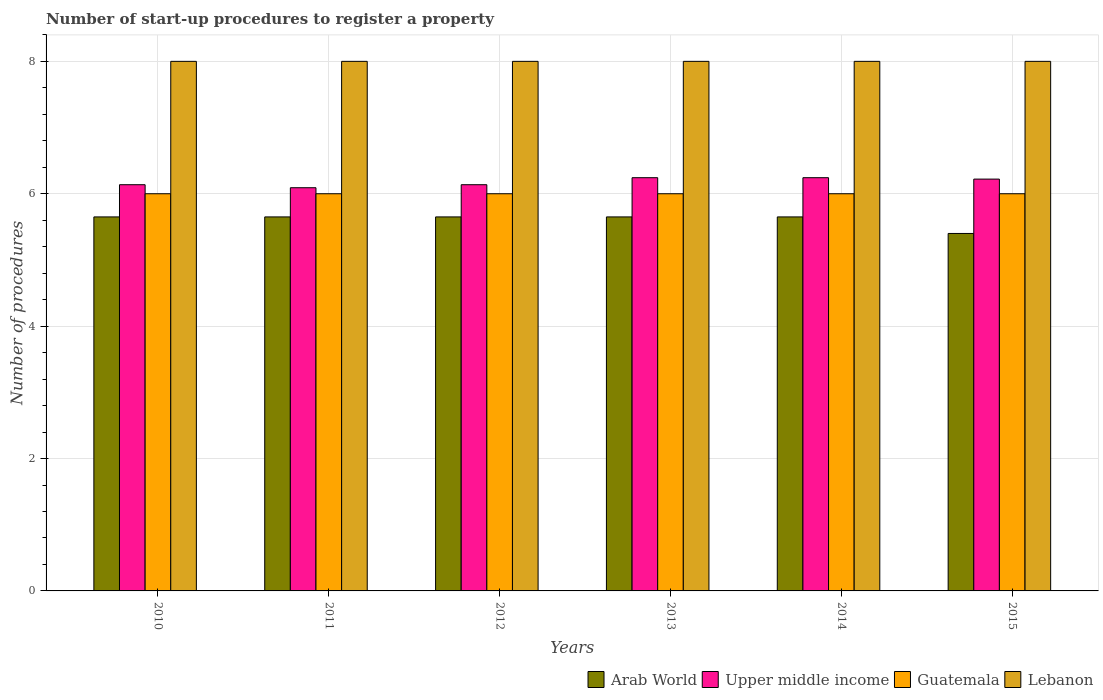Are the number of bars on each tick of the X-axis equal?
Your answer should be very brief. Yes. How many bars are there on the 2nd tick from the left?
Provide a succinct answer. 4. In how many cases, is the number of bars for a given year not equal to the number of legend labels?
Keep it short and to the point. 0. What is the number of procedures required to register a property in Lebanon in 2015?
Provide a short and direct response. 8. Across all years, what is the minimum number of procedures required to register a property in Arab World?
Give a very brief answer. 5.4. In which year was the number of procedures required to register a property in Guatemala minimum?
Make the answer very short. 2010. What is the total number of procedures required to register a property in Upper middle income in the graph?
Keep it short and to the point. 37.07. What is the difference between the number of procedures required to register a property in Upper middle income in 2014 and that in 2015?
Offer a very short reply. 0.02. What is the difference between the number of procedures required to register a property in Lebanon in 2015 and the number of procedures required to register a property in Guatemala in 2013?
Your answer should be compact. 2. What is the average number of procedures required to register a property in Lebanon per year?
Offer a very short reply. 8. In the year 2010, what is the difference between the number of procedures required to register a property in Guatemala and number of procedures required to register a property in Lebanon?
Your response must be concise. -2. In how many years, is the number of procedures required to register a property in Upper middle income greater than 7.2?
Provide a succinct answer. 0. Is the number of procedures required to register a property in Arab World in 2013 less than that in 2015?
Make the answer very short. No. What is the difference between the highest and the second highest number of procedures required to register a property in Arab World?
Offer a very short reply. 0. In how many years, is the number of procedures required to register a property in Guatemala greater than the average number of procedures required to register a property in Guatemala taken over all years?
Provide a short and direct response. 0. Is the sum of the number of procedures required to register a property in Lebanon in 2013 and 2015 greater than the maximum number of procedures required to register a property in Upper middle income across all years?
Keep it short and to the point. Yes. What does the 3rd bar from the left in 2011 represents?
Make the answer very short. Guatemala. What does the 2nd bar from the right in 2014 represents?
Your answer should be very brief. Guatemala. Are all the bars in the graph horizontal?
Provide a succinct answer. No. How many years are there in the graph?
Provide a short and direct response. 6. What is the difference between two consecutive major ticks on the Y-axis?
Keep it short and to the point. 2. Are the values on the major ticks of Y-axis written in scientific E-notation?
Ensure brevity in your answer.  No. Does the graph contain any zero values?
Offer a very short reply. No. Does the graph contain grids?
Provide a short and direct response. Yes. Where does the legend appear in the graph?
Provide a succinct answer. Bottom right. How many legend labels are there?
Your answer should be compact. 4. What is the title of the graph?
Provide a short and direct response. Number of start-up procedures to register a property. Does "Mongolia" appear as one of the legend labels in the graph?
Give a very brief answer. No. What is the label or title of the X-axis?
Give a very brief answer. Years. What is the label or title of the Y-axis?
Your answer should be very brief. Number of procedures. What is the Number of procedures in Arab World in 2010?
Provide a short and direct response. 5.65. What is the Number of procedures of Upper middle income in 2010?
Keep it short and to the point. 6.14. What is the Number of procedures in Arab World in 2011?
Give a very brief answer. 5.65. What is the Number of procedures in Upper middle income in 2011?
Provide a succinct answer. 6.09. What is the Number of procedures of Guatemala in 2011?
Your response must be concise. 6. What is the Number of procedures in Arab World in 2012?
Ensure brevity in your answer.  5.65. What is the Number of procedures of Upper middle income in 2012?
Your answer should be compact. 6.14. What is the Number of procedures in Arab World in 2013?
Provide a succinct answer. 5.65. What is the Number of procedures of Upper middle income in 2013?
Your answer should be compact. 6.24. What is the Number of procedures in Arab World in 2014?
Give a very brief answer. 5.65. What is the Number of procedures of Upper middle income in 2014?
Your answer should be very brief. 6.24. What is the Number of procedures in Lebanon in 2014?
Your answer should be very brief. 8. What is the Number of procedures of Arab World in 2015?
Keep it short and to the point. 5.4. What is the Number of procedures in Upper middle income in 2015?
Your answer should be compact. 6.22. Across all years, what is the maximum Number of procedures in Arab World?
Offer a terse response. 5.65. Across all years, what is the maximum Number of procedures in Upper middle income?
Your answer should be compact. 6.24. Across all years, what is the minimum Number of procedures of Arab World?
Provide a short and direct response. 5.4. Across all years, what is the minimum Number of procedures of Upper middle income?
Your answer should be compact. 6.09. Across all years, what is the minimum Number of procedures in Guatemala?
Your answer should be compact. 6. What is the total Number of procedures in Arab World in the graph?
Offer a terse response. 33.65. What is the total Number of procedures of Upper middle income in the graph?
Give a very brief answer. 37.07. What is the total Number of procedures of Lebanon in the graph?
Keep it short and to the point. 48. What is the difference between the Number of procedures of Upper middle income in 2010 and that in 2011?
Make the answer very short. 0.05. What is the difference between the Number of procedures in Lebanon in 2010 and that in 2011?
Make the answer very short. 0. What is the difference between the Number of procedures of Arab World in 2010 and that in 2012?
Ensure brevity in your answer.  0. What is the difference between the Number of procedures of Upper middle income in 2010 and that in 2012?
Offer a terse response. 0. What is the difference between the Number of procedures in Guatemala in 2010 and that in 2012?
Your answer should be very brief. 0. What is the difference between the Number of procedures in Lebanon in 2010 and that in 2012?
Give a very brief answer. 0. What is the difference between the Number of procedures of Upper middle income in 2010 and that in 2013?
Your answer should be very brief. -0.11. What is the difference between the Number of procedures in Lebanon in 2010 and that in 2013?
Give a very brief answer. 0. What is the difference between the Number of procedures in Arab World in 2010 and that in 2014?
Offer a very short reply. 0. What is the difference between the Number of procedures of Upper middle income in 2010 and that in 2014?
Make the answer very short. -0.11. What is the difference between the Number of procedures in Guatemala in 2010 and that in 2014?
Provide a succinct answer. 0. What is the difference between the Number of procedures of Arab World in 2010 and that in 2015?
Provide a short and direct response. 0.25. What is the difference between the Number of procedures in Upper middle income in 2010 and that in 2015?
Provide a succinct answer. -0.08. What is the difference between the Number of procedures of Guatemala in 2010 and that in 2015?
Provide a short and direct response. 0. What is the difference between the Number of procedures in Lebanon in 2010 and that in 2015?
Give a very brief answer. 0. What is the difference between the Number of procedures of Upper middle income in 2011 and that in 2012?
Provide a succinct answer. -0.05. What is the difference between the Number of procedures of Guatemala in 2011 and that in 2012?
Your answer should be compact. 0. What is the difference between the Number of procedures of Lebanon in 2011 and that in 2012?
Make the answer very short. 0. What is the difference between the Number of procedures in Arab World in 2011 and that in 2013?
Give a very brief answer. 0. What is the difference between the Number of procedures in Upper middle income in 2011 and that in 2013?
Keep it short and to the point. -0.15. What is the difference between the Number of procedures of Guatemala in 2011 and that in 2013?
Your answer should be compact. 0. What is the difference between the Number of procedures in Lebanon in 2011 and that in 2013?
Give a very brief answer. 0. What is the difference between the Number of procedures in Arab World in 2011 and that in 2014?
Keep it short and to the point. 0. What is the difference between the Number of procedures in Upper middle income in 2011 and that in 2014?
Your answer should be very brief. -0.15. What is the difference between the Number of procedures of Guatemala in 2011 and that in 2014?
Provide a succinct answer. 0. What is the difference between the Number of procedures of Lebanon in 2011 and that in 2014?
Your answer should be compact. 0. What is the difference between the Number of procedures in Arab World in 2011 and that in 2015?
Your answer should be compact. 0.25. What is the difference between the Number of procedures in Upper middle income in 2011 and that in 2015?
Keep it short and to the point. -0.13. What is the difference between the Number of procedures of Guatemala in 2011 and that in 2015?
Your answer should be very brief. 0. What is the difference between the Number of procedures of Lebanon in 2011 and that in 2015?
Make the answer very short. 0. What is the difference between the Number of procedures in Arab World in 2012 and that in 2013?
Your response must be concise. 0. What is the difference between the Number of procedures in Upper middle income in 2012 and that in 2013?
Keep it short and to the point. -0.11. What is the difference between the Number of procedures of Lebanon in 2012 and that in 2013?
Your response must be concise. 0. What is the difference between the Number of procedures in Arab World in 2012 and that in 2014?
Offer a terse response. 0. What is the difference between the Number of procedures of Upper middle income in 2012 and that in 2014?
Give a very brief answer. -0.11. What is the difference between the Number of procedures in Guatemala in 2012 and that in 2014?
Give a very brief answer. 0. What is the difference between the Number of procedures of Lebanon in 2012 and that in 2014?
Give a very brief answer. 0. What is the difference between the Number of procedures of Upper middle income in 2012 and that in 2015?
Make the answer very short. -0.08. What is the difference between the Number of procedures of Lebanon in 2012 and that in 2015?
Give a very brief answer. 0. What is the difference between the Number of procedures in Guatemala in 2013 and that in 2014?
Your response must be concise. 0. What is the difference between the Number of procedures of Upper middle income in 2013 and that in 2015?
Offer a terse response. 0.02. What is the difference between the Number of procedures of Guatemala in 2013 and that in 2015?
Provide a short and direct response. 0. What is the difference between the Number of procedures of Lebanon in 2013 and that in 2015?
Make the answer very short. 0. What is the difference between the Number of procedures in Arab World in 2014 and that in 2015?
Give a very brief answer. 0.25. What is the difference between the Number of procedures in Upper middle income in 2014 and that in 2015?
Give a very brief answer. 0.02. What is the difference between the Number of procedures of Guatemala in 2014 and that in 2015?
Offer a terse response. 0. What is the difference between the Number of procedures in Lebanon in 2014 and that in 2015?
Your response must be concise. 0. What is the difference between the Number of procedures in Arab World in 2010 and the Number of procedures in Upper middle income in 2011?
Provide a succinct answer. -0.44. What is the difference between the Number of procedures of Arab World in 2010 and the Number of procedures of Guatemala in 2011?
Offer a very short reply. -0.35. What is the difference between the Number of procedures of Arab World in 2010 and the Number of procedures of Lebanon in 2011?
Provide a succinct answer. -2.35. What is the difference between the Number of procedures of Upper middle income in 2010 and the Number of procedures of Guatemala in 2011?
Your answer should be compact. 0.14. What is the difference between the Number of procedures in Upper middle income in 2010 and the Number of procedures in Lebanon in 2011?
Ensure brevity in your answer.  -1.86. What is the difference between the Number of procedures of Arab World in 2010 and the Number of procedures of Upper middle income in 2012?
Make the answer very short. -0.49. What is the difference between the Number of procedures of Arab World in 2010 and the Number of procedures of Guatemala in 2012?
Keep it short and to the point. -0.35. What is the difference between the Number of procedures in Arab World in 2010 and the Number of procedures in Lebanon in 2012?
Your answer should be compact. -2.35. What is the difference between the Number of procedures in Upper middle income in 2010 and the Number of procedures in Guatemala in 2012?
Your answer should be very brief. 0.14. What is the difference between the Number of procedures of Upper middle income in 2010 and the Number of procedures of Lebanon in 2012?
Offer a very short reply. -1.86. What is the difference between the Number of procedures in Arab World in 2010 and the Number of procedures in Upper middle income in 2013?
Offer a very short reply. -0.59. What is the difference between the Number of procedures in Arab World in 2010 and the Number of procedures in Guatemala in 2013?
Give a very brief answer. -0.35. What is the difference between the Number of procedures of Arab World in 2010 and the Number of procedures of Lebanon in 2013?
Ensure brevity in your answer.  -2.35. What is the difference between the Number of procedures of Upper middle income in 2010 and the Number of procedures of Guatemala in 2013?
Your answer should be very brief. 0.14. What is the difference between the Number of procedures of Upper middle income in 2010 and the Number of procedures of Lebanon in 2013?
Make the answer very short. -1.86. What is the difference between the Number of procedures in Guatemala in 2010 and the Number of procedures in Lebanon in 2013?
Your answer should be very brief. -2. What is the difference between the Number of procedures of Arab World in 2010 and the Number of procedures of Upper middle income in 2014?
Your answer should be very brief. -0.59. What is the difference between the Number of procedures in Arab World in 2010 and the Number of procedures in Guatemala in 2014?
Your response must be concise. -0.35. What is the difference between the Number of procedures of Arab World in 2010 and the Number of procedures of Lebanon in 2014?
Your answer should be compact. -2.35. What is the difference between the Number of procedures in Upper middle income in 2010 and the Number of procedures in Guatemala in 2014?
Provide a succinct answer. 0.14. What is the difference between the Number of procedures in Upper middle income in 2010 and the Number of procedures in Lebanon in 2014?
Ensure brevity in your answer.  -1.86. What is the difference between the Number of procedures in Guatemala in 2010 and the Number of procedures in Lebanon in 2014?
Ensure brevity in your answer.  -2. What is the difference between the Number of procedures of Arab World in 2010 and the Number of procedures of Upper middle income in 2015?
Provide a short and direct response. -0.57. What is the difference between the Number of procedures of Arab World in 2010 and the Number of procedures of Guatemala in 2015?
Provide a succinct answer. -0.35. What is the difference between the Number of procedures in Arab World in 2010 and the Number of procedures in Lebanon in 2015?
Offer a very short reply. -2.35. What is the difference between the Number of procedures of Upper middle income in 2010 and the Number of procedures of Guatemala in 2015?
Offer a very short reply. 0.14. What is the difference between the Number of procedures in Upper middle income in 2010 and the Number of procedures in Lebanon in 2015?
Ensure brevity in your answer.  -1.86. What is the difference between the Number of procedures of Guatemala in 2010 and the Number of procedures of Lebanon in 2015?
Provide a short and direct response. -2. What is the difference between the Number of procedures in Arab World in 2011 and the Number of procedures in Upper middle income in 2012?
Ensure brevity in your answer.  -0.49. What is the difference between the Number of procedures of Arab World in 2011 and the Number of procedures of Guatemala in 2012?
Give a very brief answer. -0.35. What is the difference between the Number of procedures in Arab World in 2011 and the Number of procedures in Lebanon in 2012?
Provide a succinct answer. -2.35. What is the difference between the Number of procedures in Upper middle income in 2011 and the Number of procedures in Guatemala in 2012?
Your answer should be very brief. 0.09. What is the difference between the Number of procedures of Upper middle income in 2011 and the Number of procedures of Lebanon in 2012?
Your response must be concise. -1.91. What is the difference between the Number of procedures in Guatemala in 2011 and the Number of procedures in Lebanon in 2012?
Your answer should be very brief. -2. What is the difference between the Number of procedures in Arab World in 2011 and the Number of procedures in Upper middle income in 2013?
Ensure brevity in your answer.  -0.59. What is the difference between the Number of procedures of Arab World in 2011 and the Number of procedures of Guatemala in 2013?
Provide a succinct answer. -0.35. What is the difference between the Number of procedures of Arab World in 2011 and the Number of procedures of Lebanon in 2013?
Offer a very short reply. -2.35. What is the difference between the Number of procedures in Upper middle income in 2011 and the Number of procedures in Guatemala in 2013?
Offer a terse response. 0.09. What is the difference between the Number of procedures of Upper middle income in 2011 and the Number of procedures of Lebanon in 2013?
Keep it short and to the point. -1.91. What is the difference between the Number of procedures of Arab World in 2011 and the Number of procedures of Upper middle income in 2014?
Your response must be concise. -0.59. What is the difference between the Number of procedures of Arab World in 2011 and the Number of procedures of Guatemala in 2014?
Make the answer very short. -0.35. What is the difference between the Number of procedures of Arab World in 2011 and the Number of procedures of Lebanon in 2014?
Keep it short and to the point. -2.35. What is the difference between the Number of procedures in Upper middle income in 2011 and the Number of procedures in Guatemala in 2014?
Offer a very short reply. 0.09. What is the difference between the Number of procedures of Upper middle income in 2011 and the Number of procedures of Lebanon in 2014?
Offer a very short reply. -1.91. What is the difference between the Number of procedures of Arab World in 2011 and the Number of procedures of Upper middle income in 2015?
Ensure brevity in your answer.  -0.57. What is the difference between the Number of procedures of Arab World in 2011 and the Number of procedures of Guatemala in 2015?
Give a very brief answer. -0.35. What is the difference between the Number of procedures in Arab World in 2011 and the Number of procedures in Lebanon in 2015?
Provide a succinct answer. -2.35. What is the difference between the Number of procedures of Upper middle income in 2011 and the Number of procedures of Guatemala in 2015?
Your answer should be compact. 0.09. What is the difference between the Number of procedures of Upper middle income in 2011 and the Number of procedures of Lebanon in 2015?
Keep it short and to the point. -1.91. What is the difference between the Number of procedures in Guatemala in 2011 and the Number of procedures in Lebanon in 2015?
Ensure brevity in your answer.  -2. What is the difference between the Number of procedures in Arab World in 2012 and the Number of procedures in Upper middle income in 2013?
Offer a terse response. -0.59. What is the difference between the Number of procedures in Arab World in 2012 and the Number of procedures in Guatemala in 2013?
Offer a very short reply. -0.35. What is the difference between the Number of procedures of Arab World in 2012 and the Number of procedures of Lebanon in 2013?
Your answer should be very brief. -2.35. What is the difference between the Number of procedures of Upper middle income in 2012 and the Number of procedures of Guatemala in 2013?
Offer a terse response. 0.14. What is the difference between the Number of procedures of Upper middle income in 2012 and the Number of procedures of Lebanon in 2013?
Your response must be concise. -1.86. What is the difference between the Number of procedures of Arab World in 2012 and the Number of procedures of Upper middle income in 2014?
Your response must be concise. -0.59. What is the difference between the Number of procedures of Arab World in 2012 and the Number of procedures of Guatemala in 2014?
Your answer should be compact. -0.35. What is the difference between the Number of procedures of Arab World in 2012 and the Number of procedures of Lebanon in 2014?
Your response must be concise. -2.35. What is the difference between the Number of procedures of Upper middle income in 2012 and the Number of procedures of Guatemala in 2014?
Give a very brief answer. 0.14. What is the difference between the Number of procedures of Upper middle income in 2012 and the Number of procedures of Lebanon in 2014?
Offer a terse response. -1.86. What is the difference between the Number of procedures of Guatemala in 2012 and the Number of procedures of Lebanon in 2014?
Offer a terse response. -2. What is the difference between the Number of procedures of Arab World in 2012 and the Number of procedures of Upper middle income in 2015?
Keep it short and to the point. -0.57. What is the difference between the Number of procedures of Arab World in 2012 and the Number of procedures of Guatemala in 2015?
Your response must be concise. -0.35. What is the difference between the Number of procedures in Arab World in 2012 and the Number of procedures in Lebanon in 2015?
Make the answer very short. -2.35. What is the difference between the Number of procedures of Upper middle income in 2012 and the Number of procedures of Guatemala in 2015?
Ensure brevity in your answer.  0.14. What is the difference between the Number of procedures in Upper middle income in 2012 and the Number of procedures in Lebanon in 2015?
Offer a very short reply. -1.86. What is the difference between the Number of procedures of Arab World in 2013 and the Number of procedures of Upper middle income in 2014?
Your answer should be very brief. -0.59. What is the difference between the Number of procedures in Arab World in 2013 and the Number of procedures in Guatemala in 2014?
Give a very brief answer. -0.35. What is the difference between the Number of procedures in Arab World in 2013 and the Number of procedures in Lebanon in 2014?
Give a very brief answer. -2.35. What is the difference between the Number of procedures of Upper middle income in 2013 and the Number of procedures of Guatemala in 2014?
Offer a terse response. 0.24. What is the difference between the Number of procedures in Upper middle income in 2013 and the Number of procedures in Lebanon in 2014?
Make the answer very short. -1.76. What is the difference between the Number of procedures of Arab World in 2013 and the Number of procedures of Upper middle income in 2015?
Provide a short and direct response. -0.57. What is the difference between the Number of procedures of Arab World in 2013 and the Number of procedures of Guatemala in 2015?
Make the answer very short. -0.35. What is the difference between the Number of procedures in Arab World in 2013 and the Number of procedures in Lebanon in 2015?
Provide a succinct answer. -2.35. What is the difference between the Number of procedures of Upper middle income in 2013 and the Number of procedures of Guatemala in 2015?
Ensure brevity in your answer.  0.24. What is the difference between the Number of procedures in Upper middle income in 2013 and the Number of procedures in Lebanon in 2015?
Make the answer very short. -1.76. What is the difference between the Number of procedures in Guatemala in 2013 and the Number of procedures in Lebanon in 2015?
Provide a short and direct response. -2. What is the difference between the Number of procedures in Arab World in 2014 and the Number of procedures in Upper middle income in 2015?
Provide a short and direct response. -0.57. What is the difference between the Number of procedures of Arab World in 2014 and the Number of procedures of Guatemala in 2015?
Your response must be concise. -0.35. What is the difference between the Number of procedures in Arab World in 2014 and the Number of procedures in Lebanon in 2015?
Provide a short and direct response. -2.35. What is the difference between the Number of procedures of Upper middle income in 2014 and the Number of procedures of Guatemala in 2015?
Offer a very short reply. 0.24. What is the difference between the Number of procedures in Upper middle income in 2014 and the Number of procedures in Lebanon in 2015?
Your response must be concise. -1.76. What is the average Number of procedures of Arab World per year?
Your response must be concise. 5.61. What is the average Number of procedures in Upper middle income per year?
Provide a succinct answer. 6.18. In the year 2010, what is the difference between the Number of procedures in Arab World and Number of procedures in Upper middle income?
Provide a short and direct response. -0.49. In the year 2010, what is the difference between the Number of procedures in Arab World and Number of procedures in Guatemala?
Offer a terse response. -0.35. In the year 2010, what is the difference between the Number of procedures of Arab World and Number of procedures of Lebanon?
Keep it short and to the point. -2.35. In the year 2010, what is the difference between the Number of procedures of Upper middle income and Number of procedures of Guatemala?
Provide a succinct answer. 0.14. In the year 2010, what is the difference between the Number of procedures in Upper middle income and Number of procedures in Lebanon?
Provide a succinct answer. -1.86. In the year 2011, what is the difference between the Number of procedures of Arab World and Number of procedures of Upper middle income?
Provide a short and direct response. -0.44. In the year 2011, what is the difference between the Number of procedures of Arab World and Number of procedures of Guatemala?
Keep it short and to the point. -0.35. In the year 2011, what is the difference between the Number of procedures in Arab World and Number of procedures in Lebanon?
Provide a short and direct response. -2.35. In the year 2011, what is the difference between the Number of procedures of Upper middle income and Number of procedures of Guatemala?
Your response must be concise. 0.09. In the year 2011, what is the difference between the Number of procedures of Upper middle income and Number of procedures of Lebanon?
Your answer should be very brief. -1.91. In the year 2012, what is the difference between the Number of procedures in Arab World and Number of procedures in Upper middle income?
Keep it short and to the point. -0.49. In the year 2012, what is the difference between the Number of procedures in Arab World and Number of procedures in Guatemala?
Your response must be concise. -0.35. In the year 2012, what is the difference between the Number of procedures in Arab World and Number of procedures in Lebanon?
Keep it short and to the point. -2.35. In the year 2012, what is the difference between the Number of procedures of Upper middle income and Number of procedures of Guatemala?
Provide a succinct answer. 0.14. In the year 2012, what is the difference between the Number of procedures in Upper middle income and Number of procedures in Lebanon?
Provide a short and direct response. -1.86. In the year 2012, what is the difference between the Number of procedures of Guatemala and Number of procedures of Lebanon?
Offer a terse response. -2. In the year 2013, what is the difference between the Number of procedures in Arab World and Number of procedures in Upper middle income?
Offer a terse response. -0.59. In the year 2013, what is the difference between the Number of procedures of Arab World and Number of procedures of Guatemala?
Give a very brief answer. -0.35. In the year 2013, what is the difference between the Number of procedures in Arab World and Number of procedures in Lebanon?
Your answer should be compact. -2.35. In the year 2013, what is the difference between the Number of procedures of Upper middle income and Number of procedures of Guatemala?
Give a very brief answer. 0.24. In the year 2013, what is the difference between the Number of procedures in Upper middle income and Number of procedures in Lebanon?
Provide a short and direct response. -1.76. In the year 2013, what is the difference between the Number of procedures of Guatemala and Number of procedures of Lebanon?
Your response must be concise. -2. In the year 2014, what is the difference between the Number of procedures in Arab World and Number of procedures in Upper middle income?
Provide a short and direct response. -0.59. In the year 2014, what is the difference between the Number of procedures in Arab World and Number of procedures in Guatemala?
Ensure brevity in your answer.  -0.35. In the year 2014, what is the difference between the Number of procedures in Arab World and Number of procedures in Lebanon?
Keep it short and to the point. -2.35. In the year 2014, what is the difference between the Number of procedures in Upper middle income and Number of procedures in Guatemala?
Offer a very short reply. 0.24. In the year 2014, what is the difference between the Number of procedures in Upper middle income and Number of procedures in Lebanon?
Ensure brevity in your answer.  -1.76. In the year 2015, what is the difference between the Number of procedures in Arab World and Number of procedures in Upper middle income?
Ensure brevity in your answer.  -0.82. In the year 2015, what is the difference between the Number of procedures in Arab World and Number of procedures in Guatemala?
Give a very brief answer. -0.6. In the year 2015, what is the difference between the Number of procedures in Upper middle income and Number of procedures in Guatemala?
Offer a terse response. 0.22. In the year 2015, what is the difference between the Number of procedures of Upper middle income and Number of procedures of Lebanon?
Your answer should be compact. -1.78. In the year 2015, what is the difference between the Number of procedures of Guatemala and Number of procedures of Lebanon?
Provide a short and direct response. -2. What is the ratio of the Number of procedures of Arab World in 2010 to that in 2011?
Give a very brief answer. 1. What is the ratio of the Number of procedures in Upper middle income in 2010 to that in 2011?
Your answer should be compact. 1.01. What is the ratio of the Number of procedures in Lebanon in 2010 to that in 2011?
Ensure brevity in your answer.  1. What is the ratio of the Number of procedures in Arab World in 2010 to that in 2012?
Provide a succinct answer. 1. What is the ratio of the Number of procedures of Lebanon in 2010 to that in 2013?
Keep it short and to the point. 1. What is the ratio of the Number of procedures of Arab World in 2010 to that in 2014?
Your response must be concise. 1. What is the ratio of the Number of procedures of Arab World in 2010 to that in 2015?
Your answer should be compact. 1.05. What is the ratio of the Number of procedures in Upper middle income in 2010 to that in 2015?
Keep it short and to the point. 0.99. What is the ratio of the Number of procedures in Guatemala in 2010 to that in 2015?
Provide a short and direct response. 1. What is the ratio of the Number of procedures in Lebanon in 2010 to that in 2015?
Provide a succinct answer. 1. What is the ratio of the Number of procedures of Arab World in 2011 to that in 2012?
Offer a terse response. 1. What is the ratio of the Number of procedures of Upper middle income in 2011 to that in 2012?
Your answer should be compact. 0.99. What is the ratio of the Number of procedures of Lebanon in 2011 to that in 2012?
Offer a very short reply. 1. What is the ratio of the Number of procedures of Upper middle income in 2011 to that in 2013?
Your answer should be very brief. 0.98. What is the ratio of the Number of procedures of Upper middle income in 2011 to that in 2014?
Make the answer very short. 0.98. What is the ratio of the Number of procedures in Guatemala in 2011 to that in 2014?
Your response must be concise. 1. What is the ratio of the Number of procedures of Arab World in 2011 to that in 2015?
Ensure brevity in your answer.  1.05. What is the ratio of the Number of procedures of Upper middle income in 2011 to that in 2015?
Keep it short and to the point. 0.98. What is the ratio of the Number of procedures in Arab World in 2012 to that in 2014?
Ensure brevity in your answer.  1. What is the ratio of the Number of procedures in Upper middle income in 2012 to that in 2014?
Offer a terse response. 0.98. What is the ratio of the Number of procedures of Guatemala in 2012 to that in 2014?
Ensure brevity in your answer.  1. What is the ratio of the Number of procedures of Arab World in 2012 to that in 2015?
Your answer should be compact. 1.05. What is the ratio of the Number of procedures in Upper middle income in 2012 to that in 2015?
Make the answer very short. 0.99. What is the ratio of the Number of procedures in Guatemala in 2012 to that in 2015?
Provide a short and direct response. 1. What is the ratio of the Number of procedures of Lebanon in 2012 to that in 2015?
Offer a very short reply. 1. What is the ratio of the Number of procedures of Arab World in 2013 to that in 2014?
Make the answer very short. 1. What is the ratio of the Number of procedures of Arab World in 2013 to that in 2015?
Provide a short and direct response. 1.05. What is the ratio of the Number of procedures in Upper middle income in 2013 to that in 2015?
Your answer should be compact. 1. What is the ratio of the Number of procedures of Guatemala in 2013 to that in 2015?
Provide a short and direct response. 1. What is the ratio of the Number of procedures in Arab World in 2014 to that in 2015?
Make the answer very short. 1.05. What is the ratio of the Number of procedures of Upper middle income in 2014 to that in 2015?
Your answer should be very brief. 1. What is the ratio of the Number of procedures in Guatemala in 2014 to that in 2015?
Provide a succinct answer. 1. What is the difference between the highest and the second highest Number of procedures in Lebanon?
Provide a short and direct response. 0. What is the difference between the highest and the lowest Number of procedures in Upper middle income?
Offer a very short reply. 0.15. What is the difference between the highest and the lowest Number of procedures in Guatemala?
Offer a terse response. 0. 